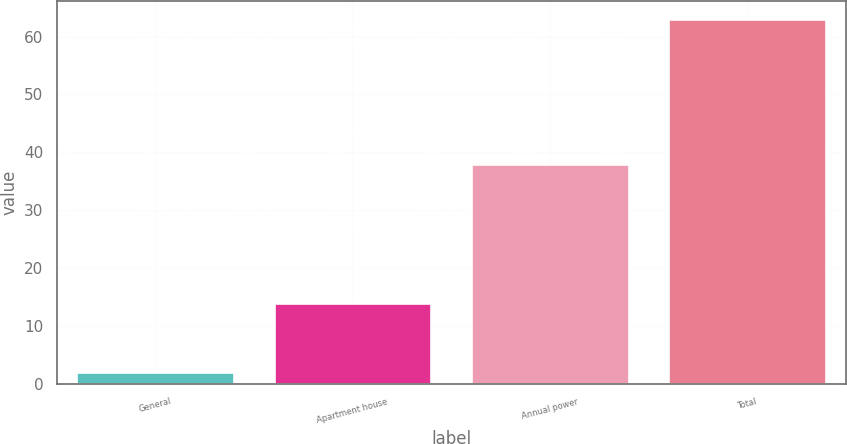Convert chart to OTSL. <chart><loc_0><loc_0><loc_500><loc_500><bar_chart><fcel>General<fcel>Apartment house<fcel>Annual power<fcel>Total<nl><fcel>2<fcel>14<fcel>38<fcel>63<nl></chart> 